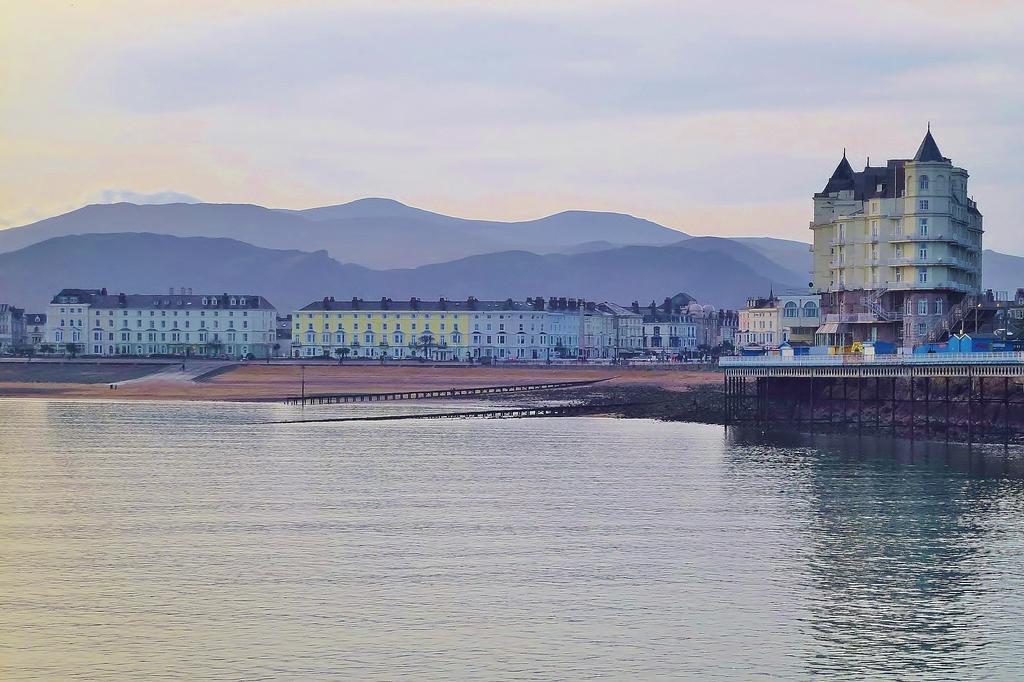Can you describe this image briefly? In this image in the center there are some buildings and poles, at the bottom there is a river. And on the right side there is a fence, and in the background there are mountains and at the top there is sky. 